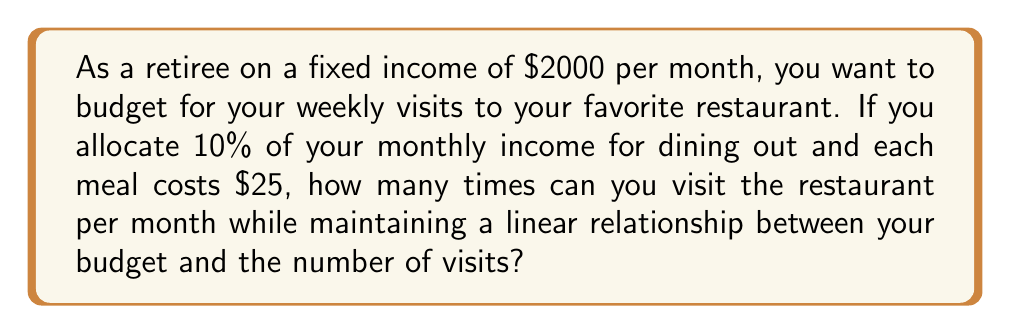Give your solution to this math problem. Let's approach this step-by-step:

1) First, calculate the monthly budget for dining out:
   10% of $2000 = $2000 * 0.10 = $200

2) Now, let's define our variables:
   Let $x$ = number of restaurant visits per month
   Let $y$ = total cost of restaurant visits per month

3) We can express this as a linear equation:
   $y = 25x$

4) We know that $y$ cannot exceed our budget of $200, so:
   $25x \leq 200$

5) To find the maximum number of visits, we solve the equation:
   $x = 200 / 25 = 8$

6) Since we can't have a fractional visit, we round down to the nearest whole number.

Therefore, the linear relationship between the budget and number of visits allows for a maximum of 8 visits per month while staying within the allocated budget.
Answer: 8 visits 